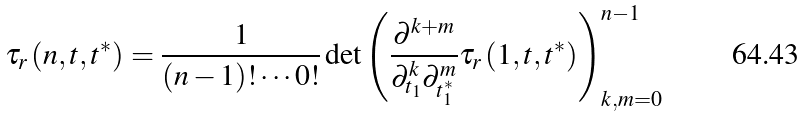Convert formula to latex. <formula><loc_0><loc_0><loc_500><loc_500>\tau _ { r } \left ( n , { t } , { t ^ { * } } \right ) = \frac { 1 } { ( n - 1 ) ! \cdots 0 ! } \det \left ( \frac { \partial ^ { k + m } } { \partial _ { t _ { 1 } } ^ { k } \partial _ { t _ { 1 } ^ { * } } ^ { m } } \tau _ { r } \left ( 1 , { t } , { t ^ { * } } \right ) \right ) _ { k , m = 0 } ^ { n - 1 }</formula> 